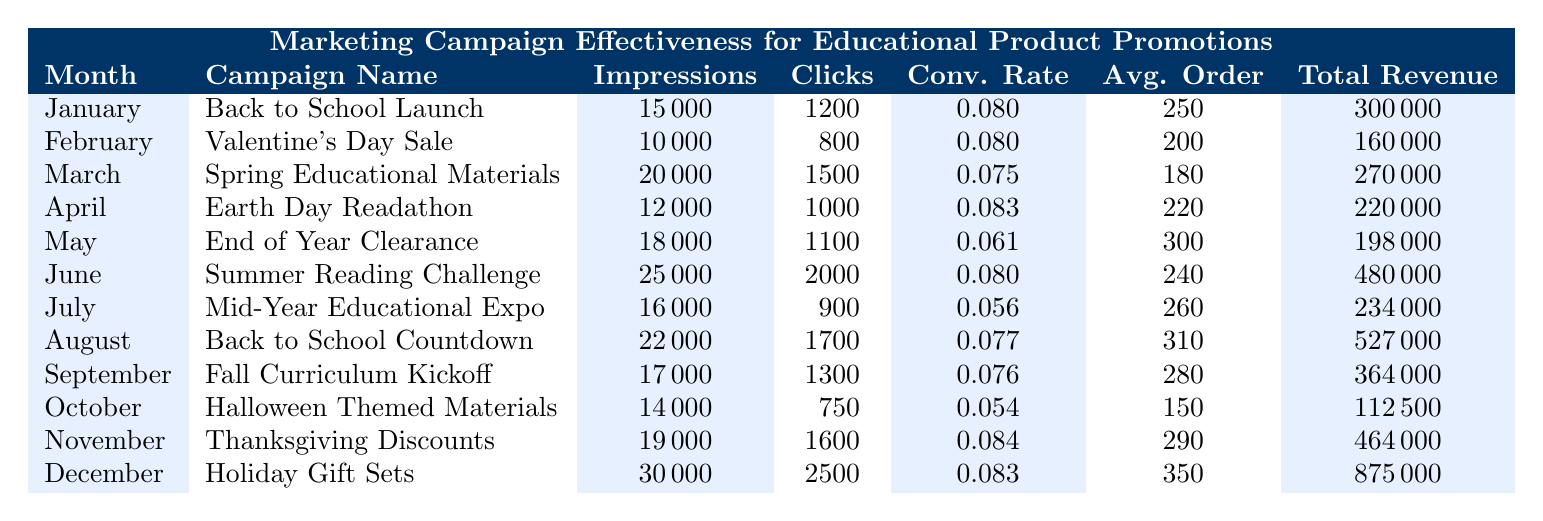What was the total revenue generated in June? From the table, the total revenue for the "Summer Reading Challenge" campaign in June is listed as 480000.
Answer: 480000 Which campaign had the highest conversion rate? The campaign with the highest conversion rate is "Thanksgiving Discounts" in November, with a conversion rate of 0.084.
Answer: Thanksgiving Discounts How many impressions were there in the month with the lowest clicks? The month with the lowest clicks is July, where the total number of impressions was 16000.
Answer: 16000 What is the average order value for campaigns run between April and June? The average order values for April, May, and June are 220, 300, and 240, respectively. The average is calculated as (220 + 300 + 240) / 3 = 253.33, which can be rounded to 253.
Answer: 253 Did the "Back to School Countdown" campaign generate more revenue than the "Fall Curriculum Kickoff" campaign? Yes, "Back to School Countdown" in August generated 527000 in revenue, while "Fall Curriculum Kickoff" in September generated 364000, making it a higher revenue campaign.
Answer: Yes Which month had the lowest total revenue, and what was that amount? The month with the lowest total revenue is October from the "Halloween Themed Materials" campaign, with a total revenue of 112500.
Answer: 112500 How many more clicks did the "Holiday Gift Sets" campaign receive compared to the "Valentine's Day Sale" campaign? The "Holiday Gift Sets" campaign in December received 2500 clicks while the "Valentine's Day Sale" campaign in February received 800 clicks. The difference is 2500 - 800 = 1700 more clicks.
Answer: 1700 Was the total revenue for January greater than that for February, and by how much? Yes, the total revenue for January is 300000 and for February is 160000. The difference is 300000 - 160000 = 140000.
Answer: 140000 What was the combined total revenue for campaigns in the second half of the year (July to December)? The total revenues for these months are July (234000), August (527000), September (364000), October (112500), November (464000), and December (875000). Adding these gives a total of 234000 + 527000 + 364000 + 112500 + 464000 + 875000 = 2071000.
Answer: 2071000 